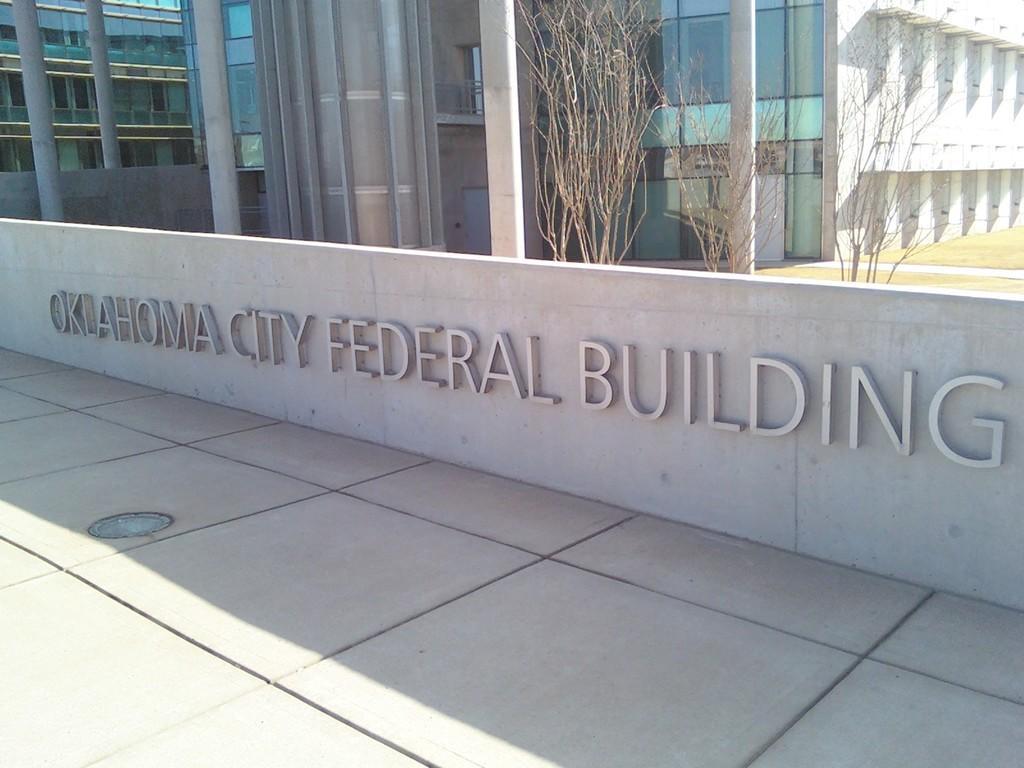In one or two sentences, can you explain what this image depicts? In this image there is a building towards the top of the image, there are dried plants, there are pillars towards the top of the image, there is a wall, there is text on the wall, there is floor towards the bottom of the image, there is an object on the floor. 